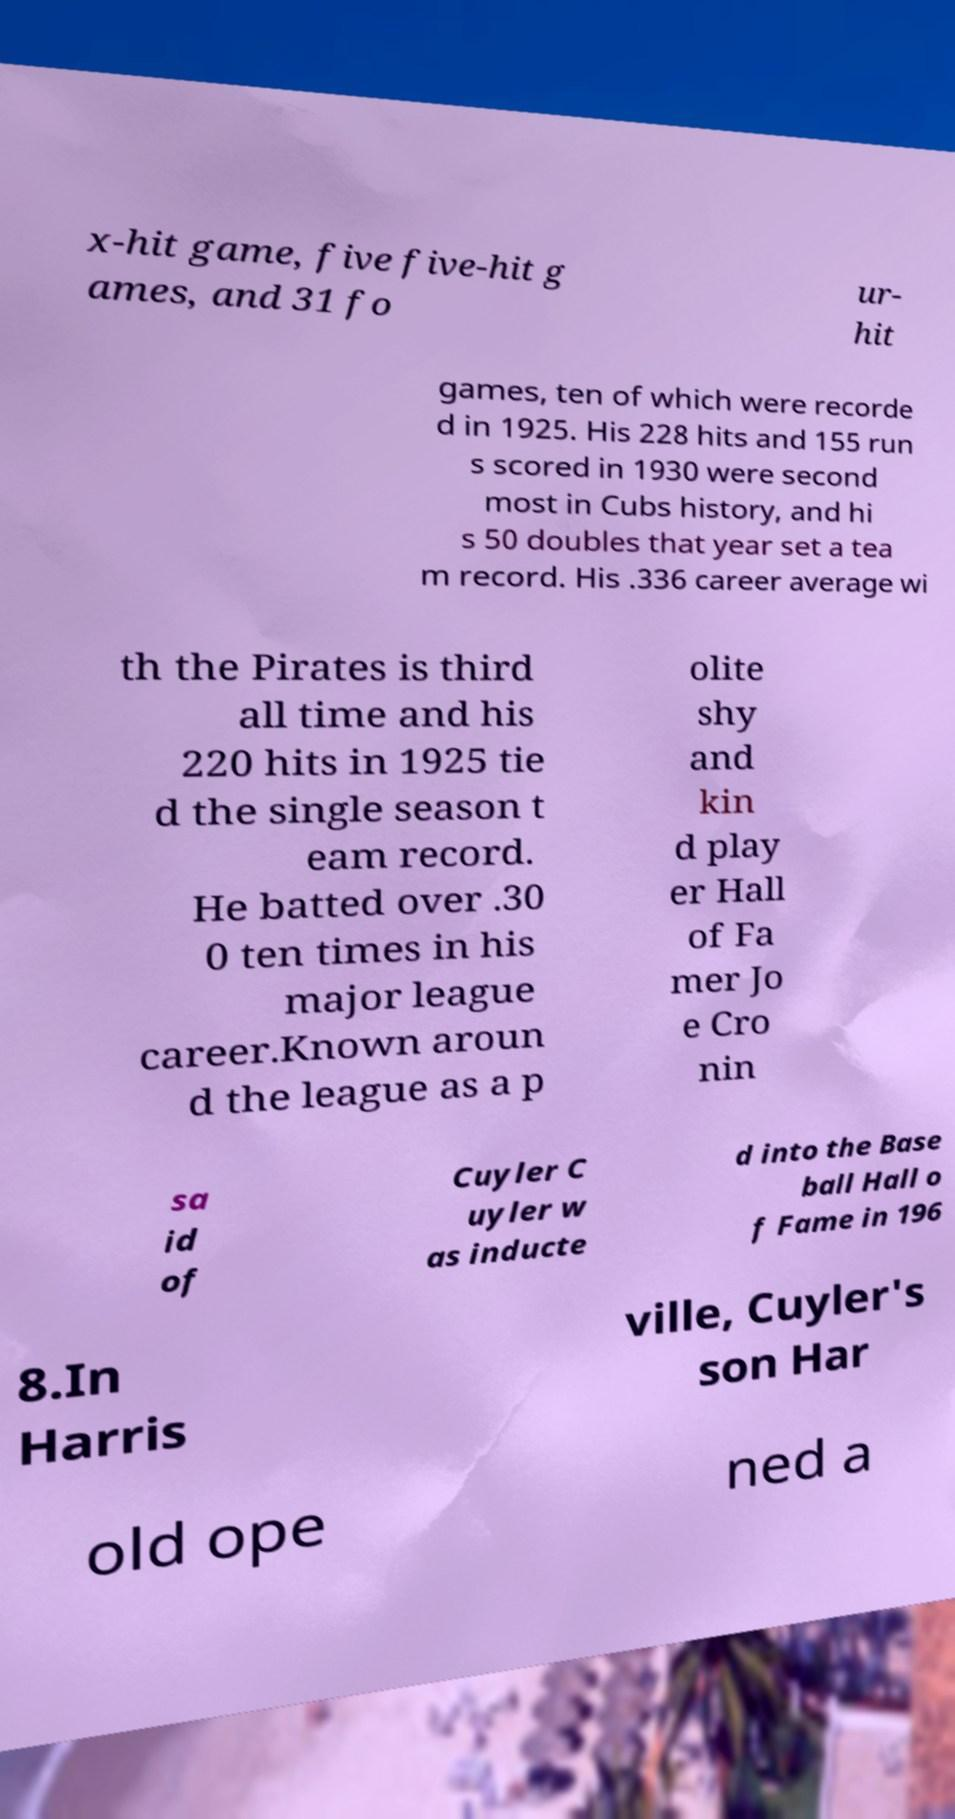Please read and relay the text visible in this image. What does it say? x-hit game, five five-hit g ames, and 31 fo ur- hit games, ten of which were recorde d in 1925. His 228 hits and 155 run s scored in 1930 were second most in Cubs history, and hi s 50 doubles that year set a tea m record. His .336 career average wi th the Pirates is third all time and his 220 hits in 1925 tie d the single season t eam record. He batted over .30 0 ten times in his major league career.Known aroun d the league as a p olite shy and kin d play er Hall of Fa mer Jo e Cro nin sa id of Cuyler C uyler w as inducte d into the Base ball Hall o f Fame in 196 8.In Harris ville, Cuyler's son Har old ope ned a 